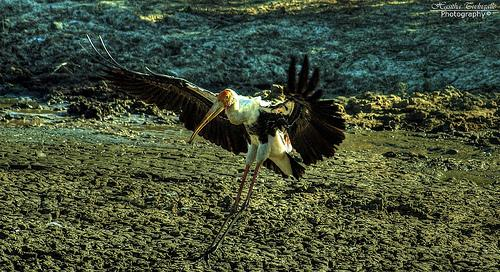Provide details about the bird's beak and wings in the image. The bird has a long white beak on its reddish-orange head and dark, outstretched wings with individual feathers curling up. Mention the notable features of the bird and the terrain where it's located. The image features a big bird with a long beak and very long legs, standing on a rough brown rocky surface with swirling water below. Provide a description of the bird's head and neck features. The bird has a reddish-orange head with a black eye, a long white beak, and a white crooked neck attached to its body. Describe the bird's physical features in detail. The bird has black wings, a white neck and lettering, a long white beak, and an orange head, as well as long skinny legs. Include the colors and description of the bird's external appearance. The bird has a mix of black, white, and orange features, including black wings, a white neck, and an orange head with a long white beak. Explain the bird's body and tail in detail. The bird has a white body with a black band around the middle, a black and white tail, and dark tail feathers fanning outwards. Explain the image's setting, focusing on the ground and water. The image shows a nature setting with medium light brown sand, small piles of water on the ground, and water in rocky depressions. Describe the bird's overall appearance and give details about its legs. The bird is a large, mostly black and white bird with extremely long, brown and orange colored skinny legs that are angled forward. Describe the bird's wing attributes and the state of the water around it. The bird has a wide wingspan with dark feathers, and it's standing near small puddles of muddy water and swirling, churning water. Mention the appearance of the bird and the terrain in the image. A large bird with black wings, white neck, orange head, and long beak is standing on a rough, brown, rocky surface with shallow water. 